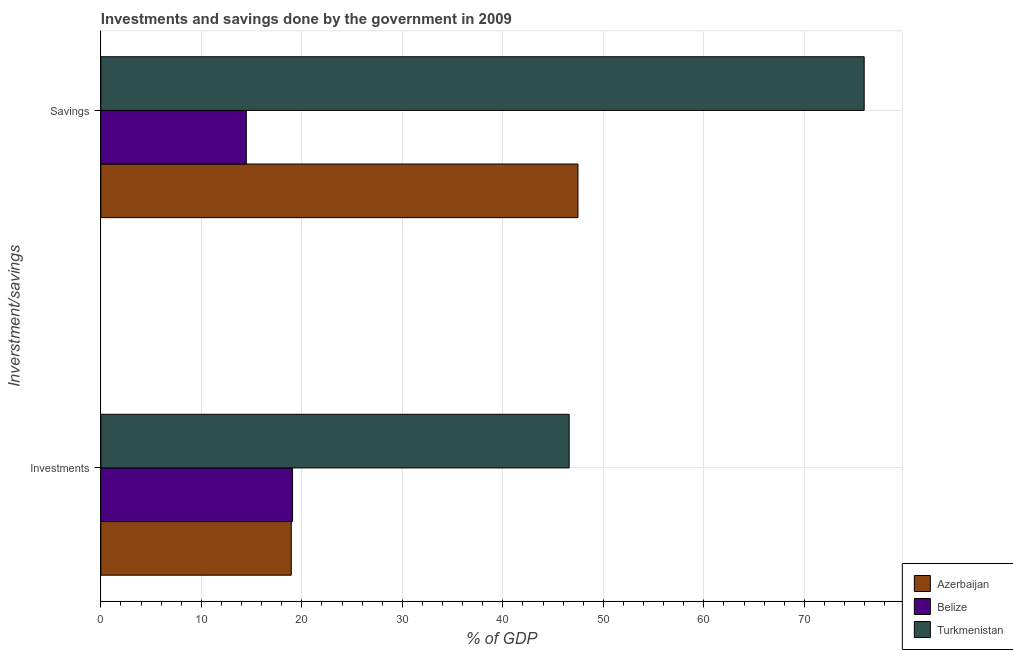What is the label of the 2nd group of bars from the top?
Your response must be concise. Investments. What is the savings of government in Turkmenistan?
Offer a very short reply. 75.96. Across all countries, what is the maximum savings of government?
Give a very brief answer. 75.96. Across all countries, what is the minimum investments of government?
Give a very brief answer. 18.95. In which country was the investments of government maximum?
Ensure brevity in your answer.  Turkmenistan. In which country was the savings of government minimum?
Your response must be concise. Belize. What is the total investments of government in the graph?
Offer a terse response. 84.62. What is the difference between the investments of government in Turkmenistan and that in Belize?
Your answer should be very brief. 27.52. What is the difference between the investments of government in Belize and the savings of government in Turkmenistan?
Offer a terse response. -56.88. What is the average savings of government per country?
Provide a succinct answer. 45.97. What is the difference between the savings of government and investments of government in Azerbaijan?
Your answer should be compact. 28.53. In how many countries, is the savings of government greater than 64 %?
Give a very brief answer. 1. What is the ratio of the savings of government in Belize to that in Turkmenistan?
Keep it short and to the point. 0.19. What does the 1st bar from the top in Savings represents?
Make the answer very short. Turkmenistan. What does the 2nd bar from the bottom in Investments represents?
Provide a short and direct response. Belize. How many bars are there?
Your response must be concise. 6. Are all the bars in the graph horizontal?
Ensure brevity in your answer.  Yes. Are the values on the major ticks of X-axis written in scientific E-notation?
Your answer should be very brief. No. How are the legend labels stacked?
Provide a succinct answer. Vertical. What is the title of the graph?
Offer a very short reply. Investments and savings done by the government in 2009. Does "El Salvador" appear as one of the legend labels in the graph?
Give a very brief answer. No. What is the label or title of the X-axis?
Offer a terse response. % of GDP. What is the label or title of the Y-axis?
Provide a short and direct response. Inverstment/savings. What is the % of GDP in Azerbaijan in Investments?
Give a very brief answer. 18.95. What is the % of GDP in Belize in Investments?
Provide a succinct answer. 19.08. What is the % of GDP of Turkmenistan in Investments?
Provide a succinct answer. 46.6. What is the % of GDP in Azerbaijan in Savings?
Provide a short and direct response. 47.48. What is the % of GDP of Belize in Savings?
Give a very brief answer. 14.48. What is the % of GDP in Turkmenistan in Savings?
Offer a very short reply. 75.96. Across all Inverstment/savings, what is the maximum % of GDP in Azerbaijan?
Provide a succinct answer. 47.48. Across all Inverstment/savings, what is the maximum % of GDP in Belize?
Ensure brevity in your answer.  19.08. Across all Inverstment/savings, what is the maximum % of GDP in Turkmenistan?
Make the answer very short. 75.96. Across all Inverstment/savings, what is the minimum % of GDP of Azerbaijan?
Give a very brief answer. 18.95. Across all Inverstment/savings, what is the minimum % of GDP of Belize?
Make the answer very short. 14.48. Across all Inverstment/savings, what is the minimum % of GDP of Turkmenistan?
Offer a very short reply. 46.6. What is the total % of GDP of Azerbaijan in the graph?
Give a very brief answer. 66.42. What is the total % of GDP of Belize in the graph?
Offer a terse response. 33.55. What is the total % of GDP of Turkmenistan in the graph?
Offer a terse response. 122.56. What is the difference between the % of GDP of Azerbaijan in Investments and that in Savings?
Offer a terse response. -28.53. What is the difference between the % of GDP in Belize in Investments and that in Savings?
Your response must be concise. 4.6. What is the difference between the % of GDP in Turkmenistan in Investments and that in Savings?
Provide a succinct answer. -29.36. What is the difference between the % of GDP of Azerbaijan in Investments and the % of GDP of Belize in Savings?
Offer a terse response. 4.47. What is the difference between the % of GDP of Azerbaijan in Investments and the % of GDP of Turkmenistan in Savings?
Your response must be concise. -57.01. What is the difference between the % of GDP of Belize in Investments and the % of GDP of Turkmenistan in Savings?
Your answer should be compact. -56.88. What is the average % of GDP in Azerbaijan per Inverstment/savings?
Make the answer very short. 33.21. What is the average % of GDP in Belize per Inverstment/savings?
Keep it short and to the point. 16.78. What is the average % of GDP in Turkmenistan per Inverstment/savings?
Make the answer very short. 61.28. What is the difference between the % of GDP of Azerbaijan and % of GDP of Belize in Investments?
Give a very brief answer. -0.13. What is the difference between the % of GDP in Azerbaijan and % of GDP in Turkmenistan in Investments?
Offer a very short reply. -27.65. What is the difference between the % of GDP of Belize and % of GDP of Turkmenistan in Investments?
Offer a very short reply. -27.52. What is the difference between the % of GDP in Azerbaijan and % of GDP in Belize in Savings?
Ensure brevity in your answer.  33. What is the difference between the % of GDP in Azerbaijan and % of GDP in Turkmenistan in Savings?
Make the answer very short. -28.48. What is the difference between the % of GDP of Belize and % of GDP of Turkmenistan in Savings?
Provide a short and direct response. -61.48. What is the ratio of the % of GDP of Azerbaijan in Investments to that in Savings?
Offer a terse response. 0.4. What is the ratio of the % of GDP of Belize in Investments to that in Savings?
Keep it short and to the point. 1.32. What is the ratio of the % of GDP in Turkmenistan in Investments to that in Savings?
Provide a succinct answer. 0.61. What is the difference between the highest and the second highest % of GDP of Azerbaijan?
Your answer should be very brief. 28.53. What is the difference between the highest and the second highest % of GDP in Belize?
Offer a very short reply. 4.6. What is the difference between the highest and the second highest % of GDP in Turkmenistan?
Provide a short and direct response. 29.36. What is the difference between the highest and the lowest % of GDP in Azerbaijan?
Provide a succinct answer. 28.53. What is the difference between the highest and the lowest % of GDP in Belize?
Keep it short and to the point. 4.6. What is the difference between the highest and the lowest % of GDP of Turkmenistan?
Offer a very short reply. 29.36. 